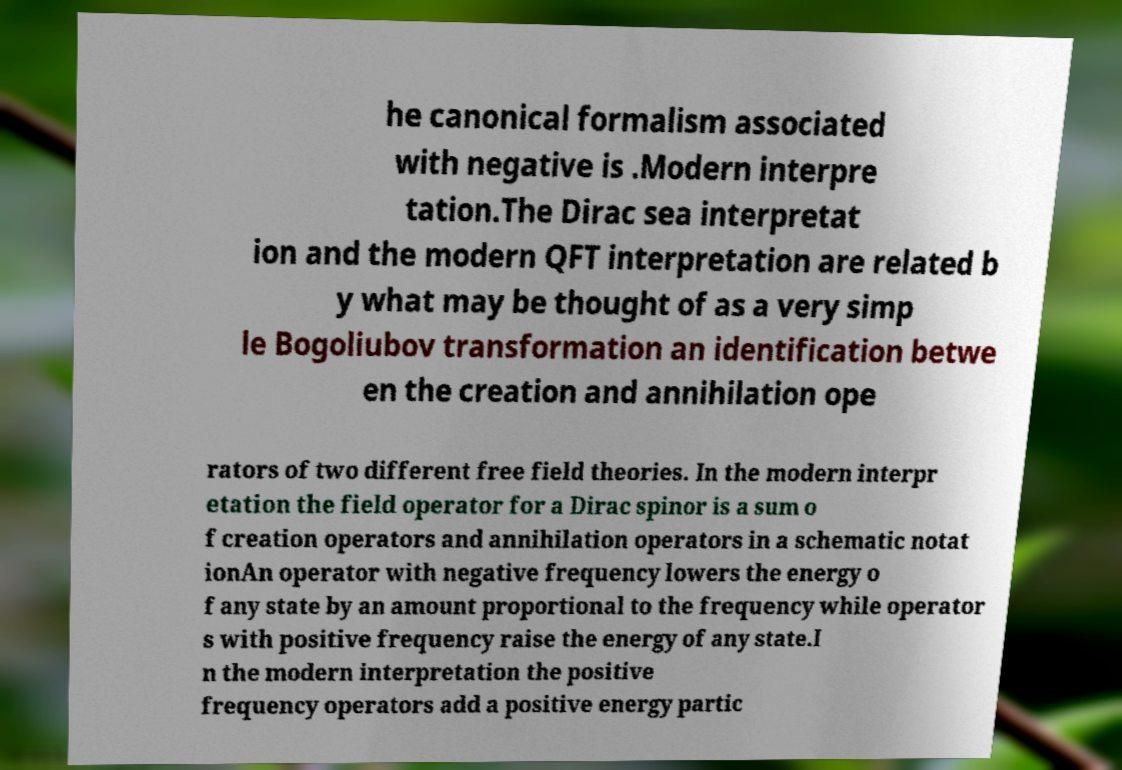There's text embedded in this image that I need extracted. Can you transcribe it verbatim? he canonical formalism associated with negative is .Modern interpre tation.The Dirac sea interpretat ion and the modern QFT interpretation are related b y what may be thought of as a very simp le Bogoliubov transformation an identification betwe en the creation and annihilation ope rators of two different free field theories. In the modern interpr etation the field operator for a Dirac spinor is a sum o f creation operators and annihilation operators in a schematic notat ionAn operator with negative frequency lowers the energy o f any state by an amount proportional to the frequency while operator s with positive frequency raise the energy of any state.I n the modern interpretation the positive frequency operators add a positive energy partic 